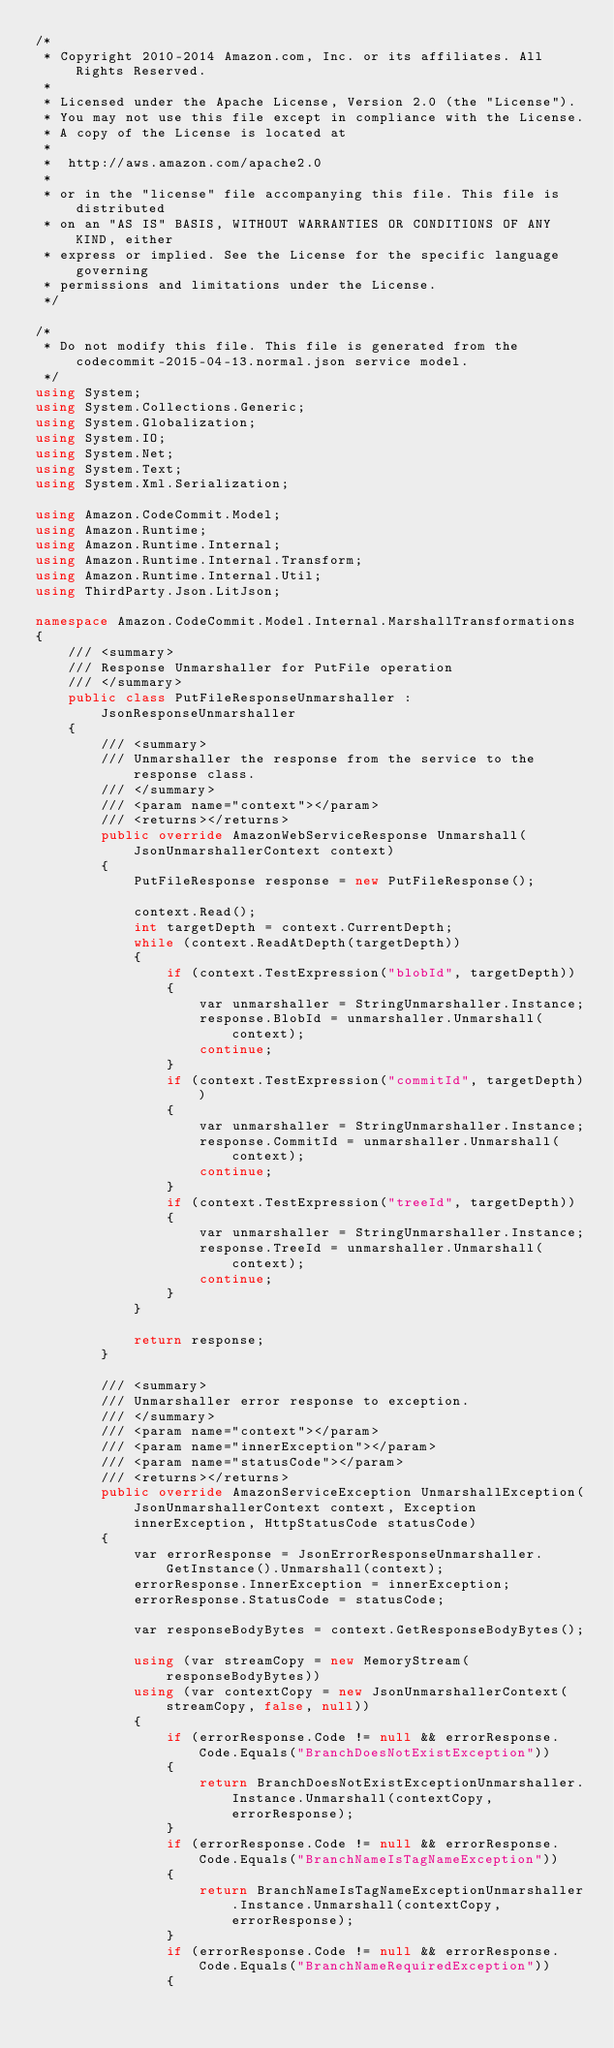Convert code to text. <code><loc_0><loc_0><loc_500><loc_500><_C#_>/*
 * Copyright 2010-2014 Amazon.com, Inc. or its affiliates. All Rights Reserved.
 * 
 * Licensed under the Apache License, Version 2.0 (the "License").
 * You may not use this file except in compliance with the License.
 * A copy of the License is located at
 * 
 *  http://aws.amazon.com/apache2.0
 * 
 * or in the "license" file accompanying this file. This file is distributed
 * on an "AS IS" BASIS, WITHOUT WARRANTIES OR CONDITIONS OF ANY KIND, either
 * express or implied. See the License for the specific language governing
 * permissions and limitations under the License.
 */

/*
 * Do not modify this file. This file is generated from the codecommit-2015-04-13.normal.json service model.
 */
using System;
using System.Collections.Generic;
using System.Globalization;
using System.IO;
using System.Net;
using System.Text;
using System.Xml.Serialization;

using Amazon.CodeCommit.Model;
using Amazon.Runtime;
using Amazon.Runtime.Internal;
using Amazon.Runtime.Internal.Transform;
using Amazon.Runtime.Internal.Util;
using ThirdParty.Json.LitJson;

namespace Amazon.CodeCommit.Model.Internal.MarshallTransformations
{
    /// <summary>
    /// Response Unmarshaller for PutFile operation
    /// </summary>  
    public class PutFileResponseUnmarshaller : JsonResponseUnmarshaller
    {
        /// <summary>
        /// Unmarshaller the response from the service to the response class.
        /// </summary>  
        /// <param name="context"></param>
        /// <returns></returns>
        public override AmazonWebServiceResponse Unmarshall(JsonUnmarshallerContext context)
        {
            PutFileResponse response = new PutFileResponse();

            context.Read();
            int targetDepth = context.CurrentDepth;
            while (context.ReadAtDepth(targetDepth))
            {
                if (context.TestExpression("blobId", targetDepth))
                {
                    var unmarshaller = StringUnmarshaller.Instance;
                    response.BlobId = unmarshaller.Unmarshall(context);
                    continue;
                }
                if (context.TestExpression("commitId", targetDepth))
                {
                    var unmarshaller = StringUnmarshaller.Instance;
                    response.CommitId = unmarshaller.Unmarshall(context);
                    continue;
                }
                if (context.TestExpression("treeId", targetDepth))
                {
                    var unmarshaller = StringUnmarshaller.Instance;
                    response.TreeId = unmarshaller.Unmarshall(context);
                    continue;
                }
            }

            return response;
        }

        /// <summary>
        /// Unmarshaller error response to exception.
        /// </summary>  
        /// <param name="context"></param>
        /// <param name="innerException"></param>
        /// <param name="statusCode"></param>
        /// <returns></returns>
        public override AmazonServiceException UnmarshallException(JsonUnmarshallerContext context, Exception innerException, HttpStatusCode statusCode)
        {
            var errorResponse = JsonErrorResponseUnmarshaller.GetInstance().Unmarshall(context);
            errorResponse.InnerException = innerException;
            errorResponse.StatusCode = statusCode;

            var responseBodyBytes = context.GetResponseBodyBytes();

            using (var streamCopy = new MemoryStream(responseBodyBytes))
            using (var contextCopy = new JsonUnmarshallerContext(streamCopy, false, null))
            {
                if (errorResponse.Code != null && errorResponse.Code.Equals("BranchDoesNotExistException"))
                {
                    return BranchDoesNotExistExceptionUnmarshaller.Instance.Unmarshall(contextCopy, errorResponse);
                }
                if (errorResponse.Code != null && errorResponse.Code.Equals("BranchNameIsTagNameException"))
                {
                    return BranchNameIsTagNameExceptionUnmarshaller.Instance.Unmarshall(contextCopy, errorResponse);
                }
                if (errorResponse.Code != null && errorResponse.Code.Equals("BranchNameRequiredException"))
                {</code> 